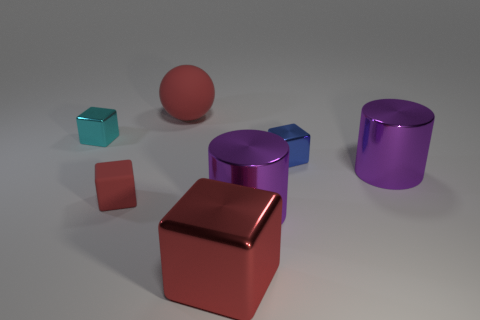Which object in the image appears to be the largest? The largest object appears to be the purple cylinder on the right. It has a significant volume and height compared to the other objects. 